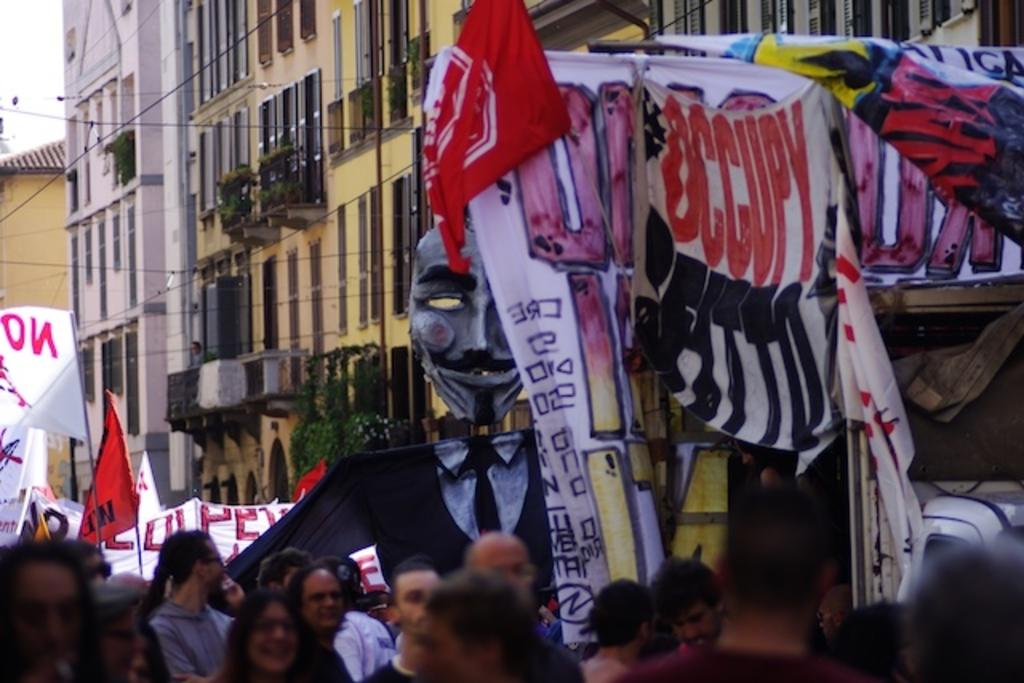What is happening at the bottom of the image? There is a group of people at the bottom of the image. What are the people holding in the image? The people are holding flags and placards. What can be seen at the top of the image? There are big buildings at the top of the image. What type of lunch is being served to the robin in the image? There is no robin or lunch present in the image. 